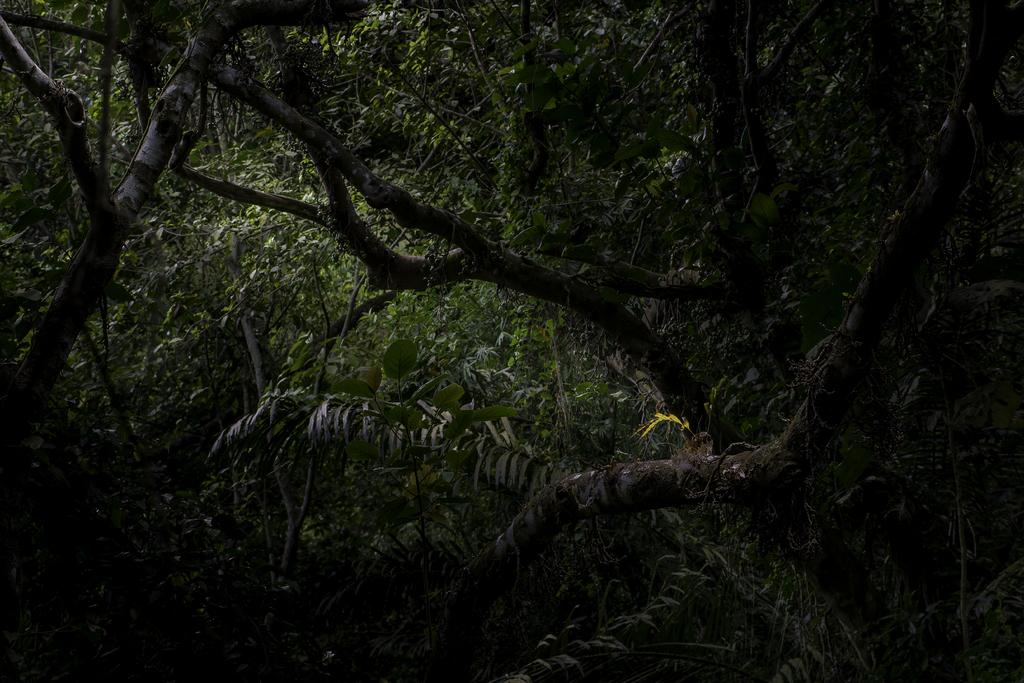What is present on the stems in the image? The stems have trees in the image. What feature do the trees possess? The trees have leaves. How does the system of dad increase in the image? There is no system or dad present in the image; it only features stems, trees, and leaves. 